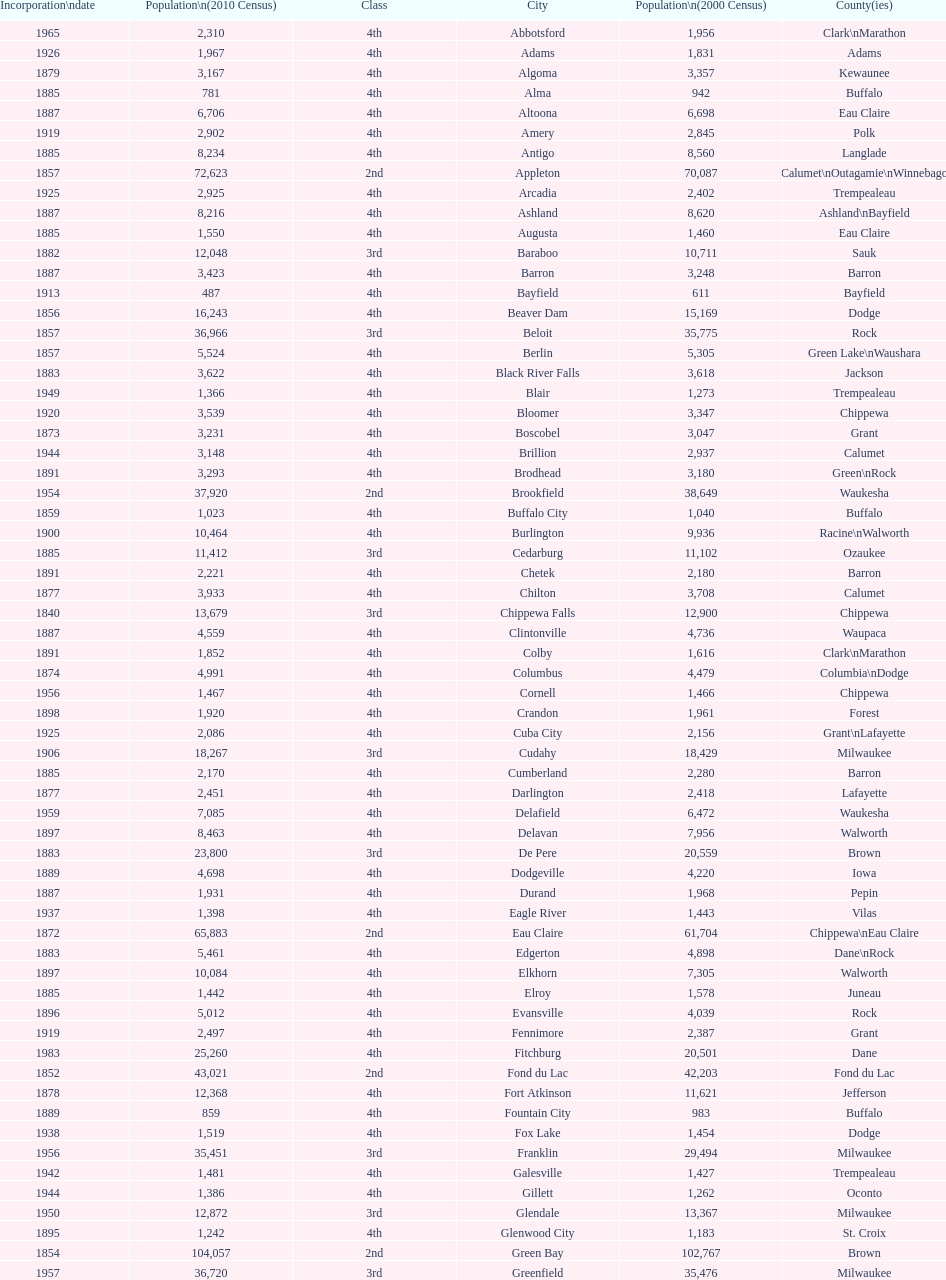How many cities are in wisconsin? 190. 